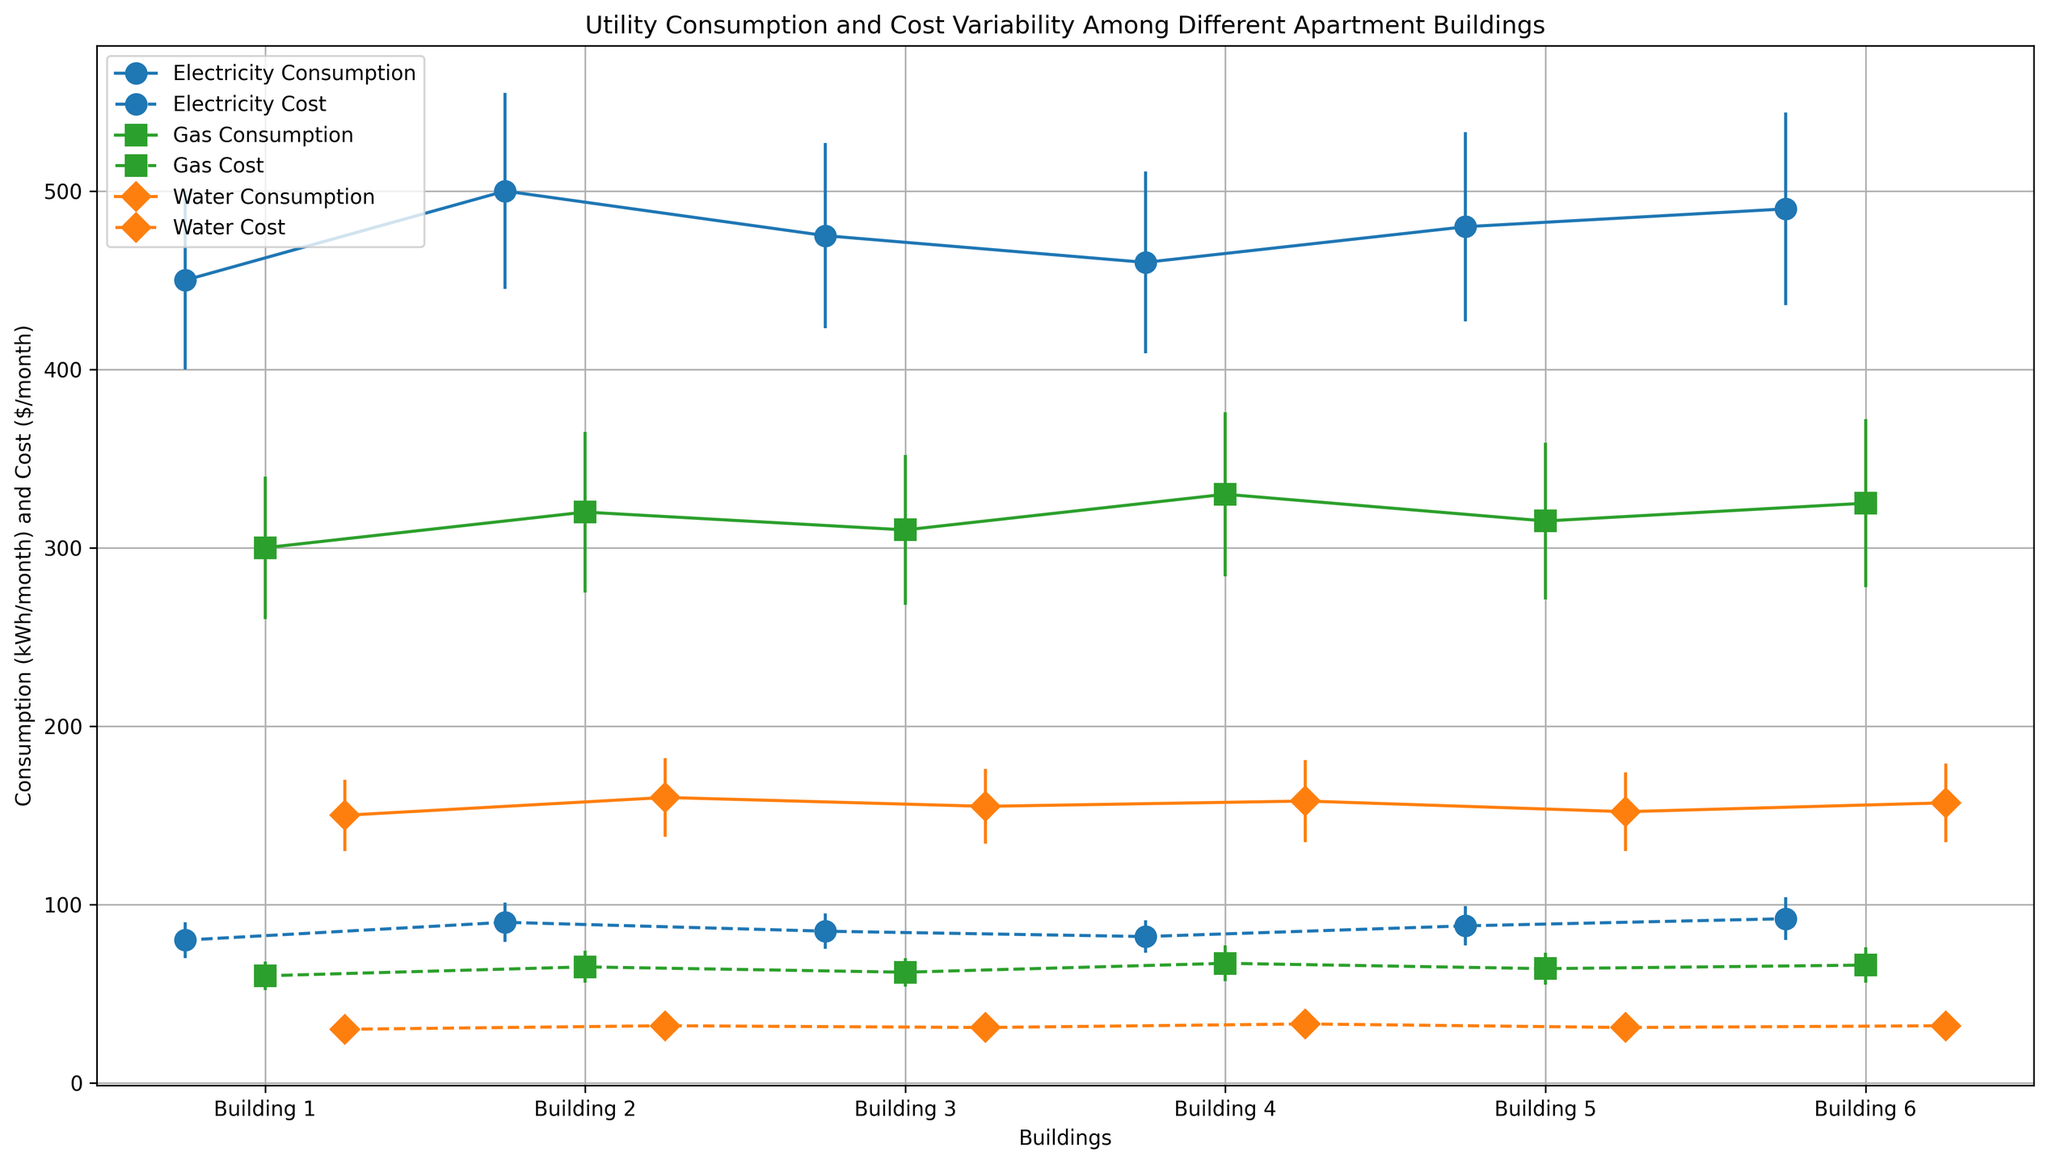Which building has the highest average electricity consumption? Building 6 has the highest average electricity consumption. This can be identified by comparing the heights of the electricity consumption markers for each building. The marker for Building 6 is clearly the highest.
Answer: Building 6 What is the average cost of water across all buildings? To find the average cost of water, add up the average costs for each building and divide by the number of buildings. (30 + 32 + 31 + 33 + 31 + 32) / 6 = 31.5
Answer: 31.5 Which utility has the most variability in gas consumption as indicated by the error bars? The variability of gas consumption can be identified by checking the length of error bars for gas consumption. Building 4 has the longest gas consumption error bars, indicating the most variability.
Answer: Building 4 Are there any buildings where the average cost of electricity is less than the average cost of gas? To determine this, compare the average costs of electricity and gas for each building. In all buildings, the average cost of electricity is higher than the average cost of gas.
Answer: No Which building has the lowest average water consumption? Building 1 has the lowest average water consumption by comparing the heights of the water consumption markers for each building. The marker for Building 1 is the lowest.
Answer: Building 1 How does the standard deviation of gas consumption for Building 6 compare to that of Building 2? The standard deviation for gas consumption in Building 6 is 47 kWh/month and for Building 2 is 45 kWh/month. Building 6 has a slightly higher standard deviation.
Answer: Building 6 Considering Buildings 2 and 3, which has a higher average cost for electricity and by how much? Building 2 has an average cost of $90/month for electricity and Building 3 has $85/month. The difference is $90 - $85 = $5.
Answer: Building 2 by $5 If you sum up the average gas consumption for Buildings 1, 4, and 6, what is the total consumption? The sum of the average gas consumption for Buildings 1, 4, and 6 is 300 + 330 + 325 = 955 kWh/month.
Answer: 955 Between the average costs and standard deviations being displayed, which utility and building combination displays the highest uncertainty for water cost? Building 4 displays the highest standard deviation for water cost, which is $7/month as indicated by the error bars.
Answer: Building 4 Compare the average consumption of electricity and gas in Building 5. Which one is higher and by how much? The average electricity consumption in Building 5 is 480 kWh/month, and the average gas consumption is 315 kWh/month. Electricity consumption is higher by 480 - 315 = 165 kWh/month.
Answer: Electricity by 165 